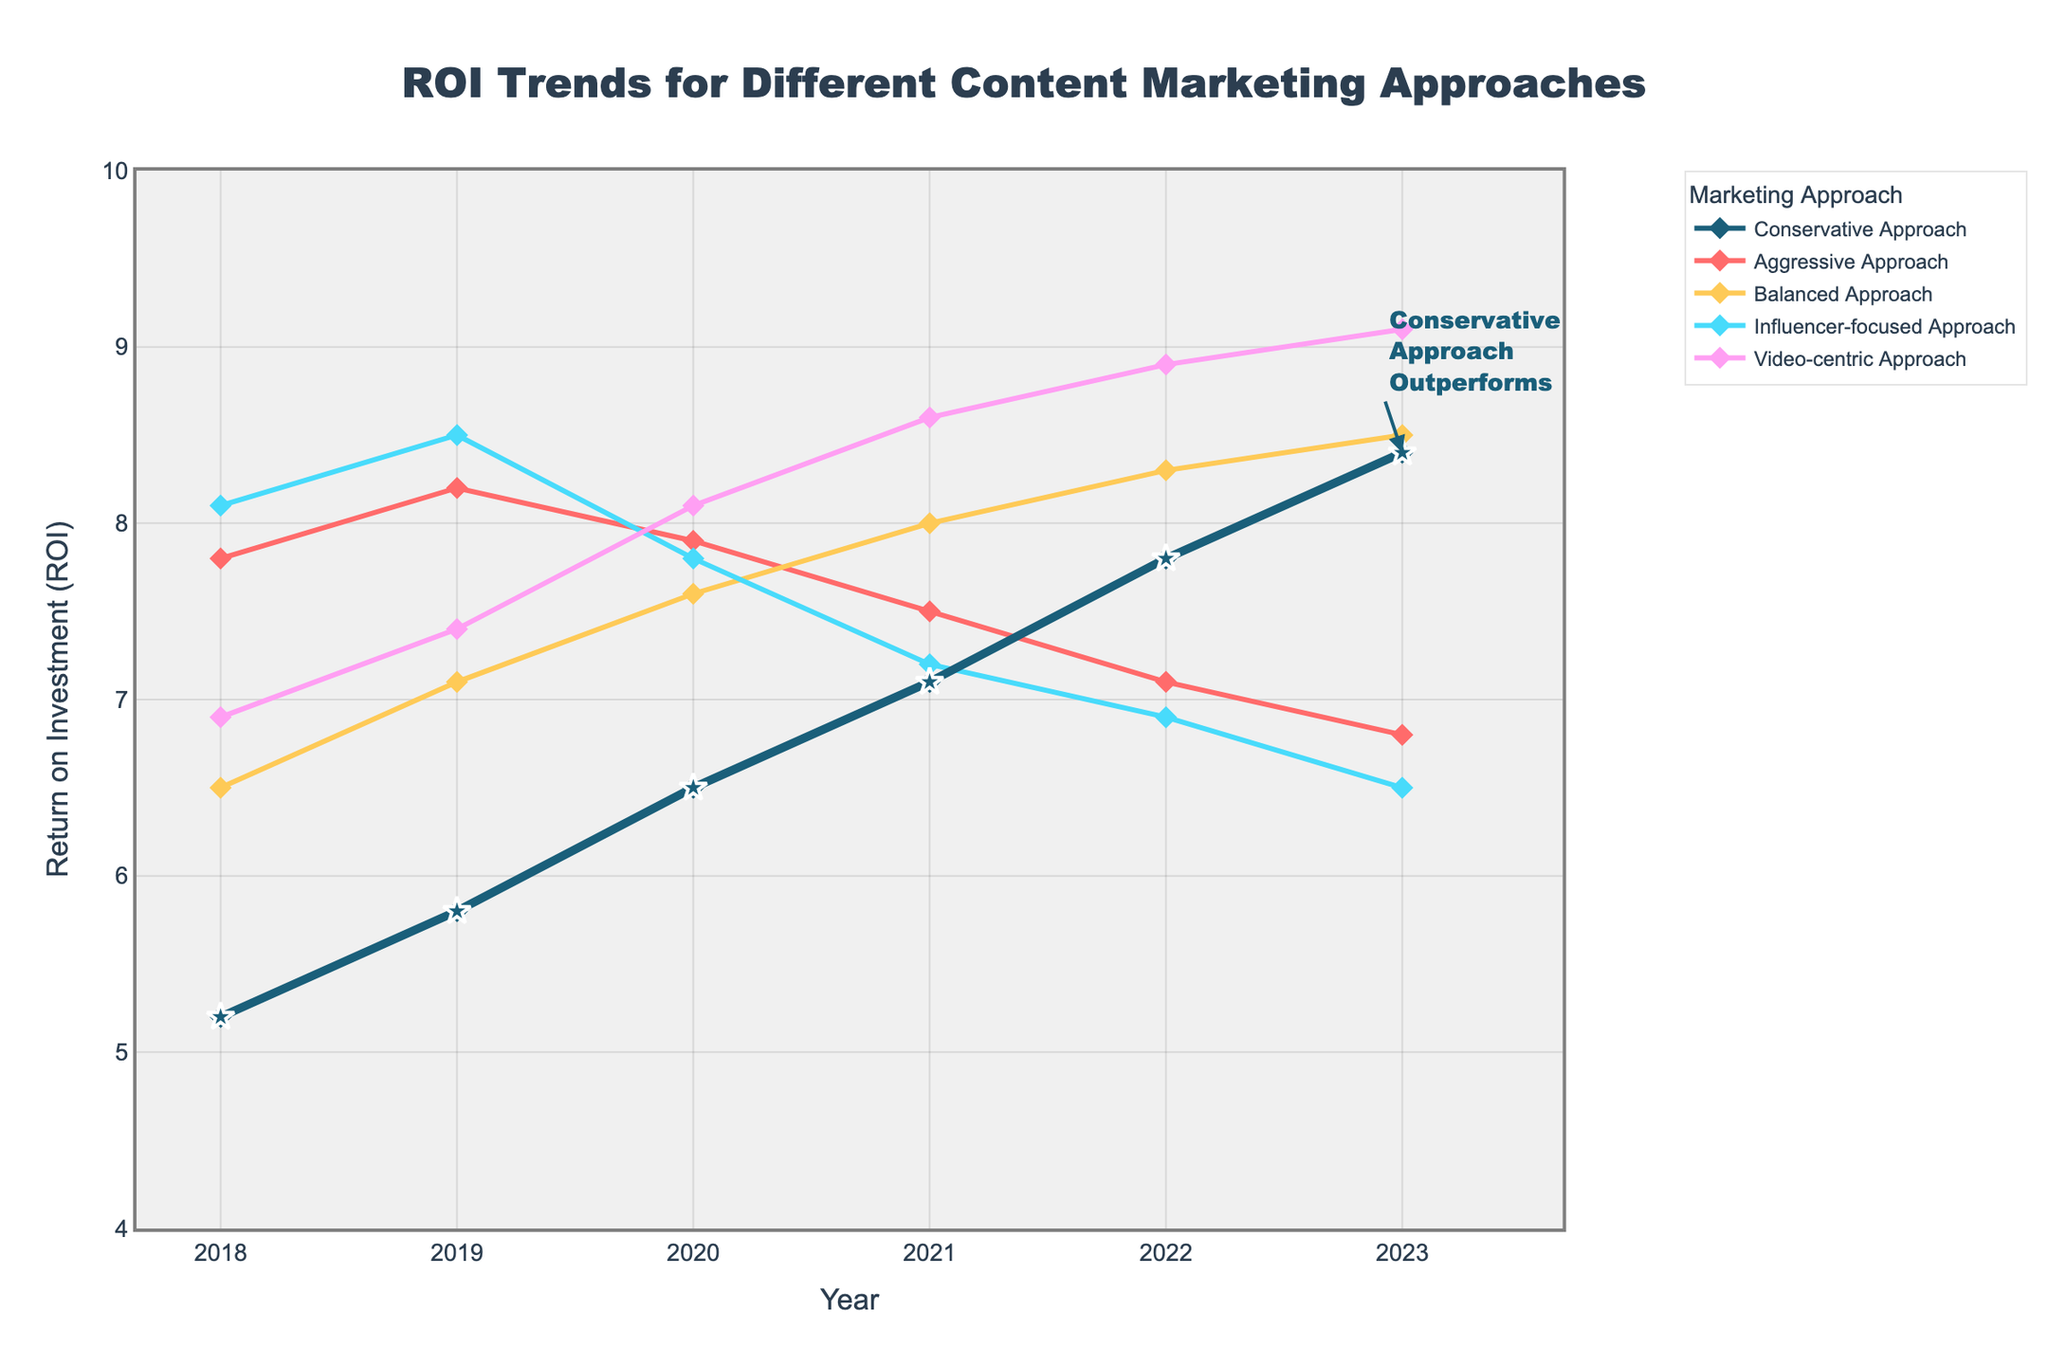What is the trend for the ROI of the Conservative Approach from 2018 to 2023? The ROI for the Conservative Approach consistently increased each year, rising from 5.2 in 2018 to 8.4 in 2023.
Answer: Consistently increasing Which marketing approach had the highest ROI in 2023? In 2023, the Video-centric Approach had the highest ROI, with a value of 9.1.
Answer: Video-centric Approach How did the ROI for the Aggressive Approach change from 2018 to 2023? The ROI for the Aggressive Approach decreased from 7.8 in 2018 to 6.8 in 2023.
Answer: Decreased What is the difference between the highest and lowest ROIs in 2023? The highest ROI in 2023 was 9.1 (Video-centric Approach) and the lowest was 6.5 (Influencer-focused Approach). The difference is 9.1 - 6.5 = 2.6.
Answer: 2.6 Which approach had a declining trend in ROI over the years? The Aggressive Approach had a declining trend, dropping from 8.2 in 2019 to 6.8 in 2023.
Answer: Aggressive Approach Was the Balanced Approach's ROI ever higher than the Influencer-focused Approach's ROI? Yes, the Balanced Approach's ROI was higher in several years, notably in 2020 (7.6 for Balanced vs. 7.8 for Influencer-focused) and continued to be higher until 2023.
Answer: Yes Compare the ROI of the Video-centric Approach in 2023 to its ROI in 2018. The ROI of the Video-centric Approach increased from 6.9 in 2018 to 9.1 in 2023.
Answer: Increased What is the average ROI of the Balanced Approach from 2018 to 2023? The average is calculated by summing the yearly ROIs for the Balanced Approach from 2018 to 2023 and dividing by the number of years: (6.5 + 7.1 + 7.6 + 8.0 + 8.3 + 8.5) / 6 = 7.67.
Answer: 7.67 In which year did the Conservative Approach see the greatest increase in ROI from the previous year? The greatest increase occurred from 2021 to 2022, with an increase of 7.8 - 7.1 = 0.7.
Answer: 2022 How does the ROI of the Conservative Approach in 2018 compare to the ROI of the Aggressive Approach in 2023? The ROI of the Conservative Approach in 2018 was 5.2, which is lower than the ROI of the Aggressive Approach in 2023 at 6.8.
Answer: Lower 